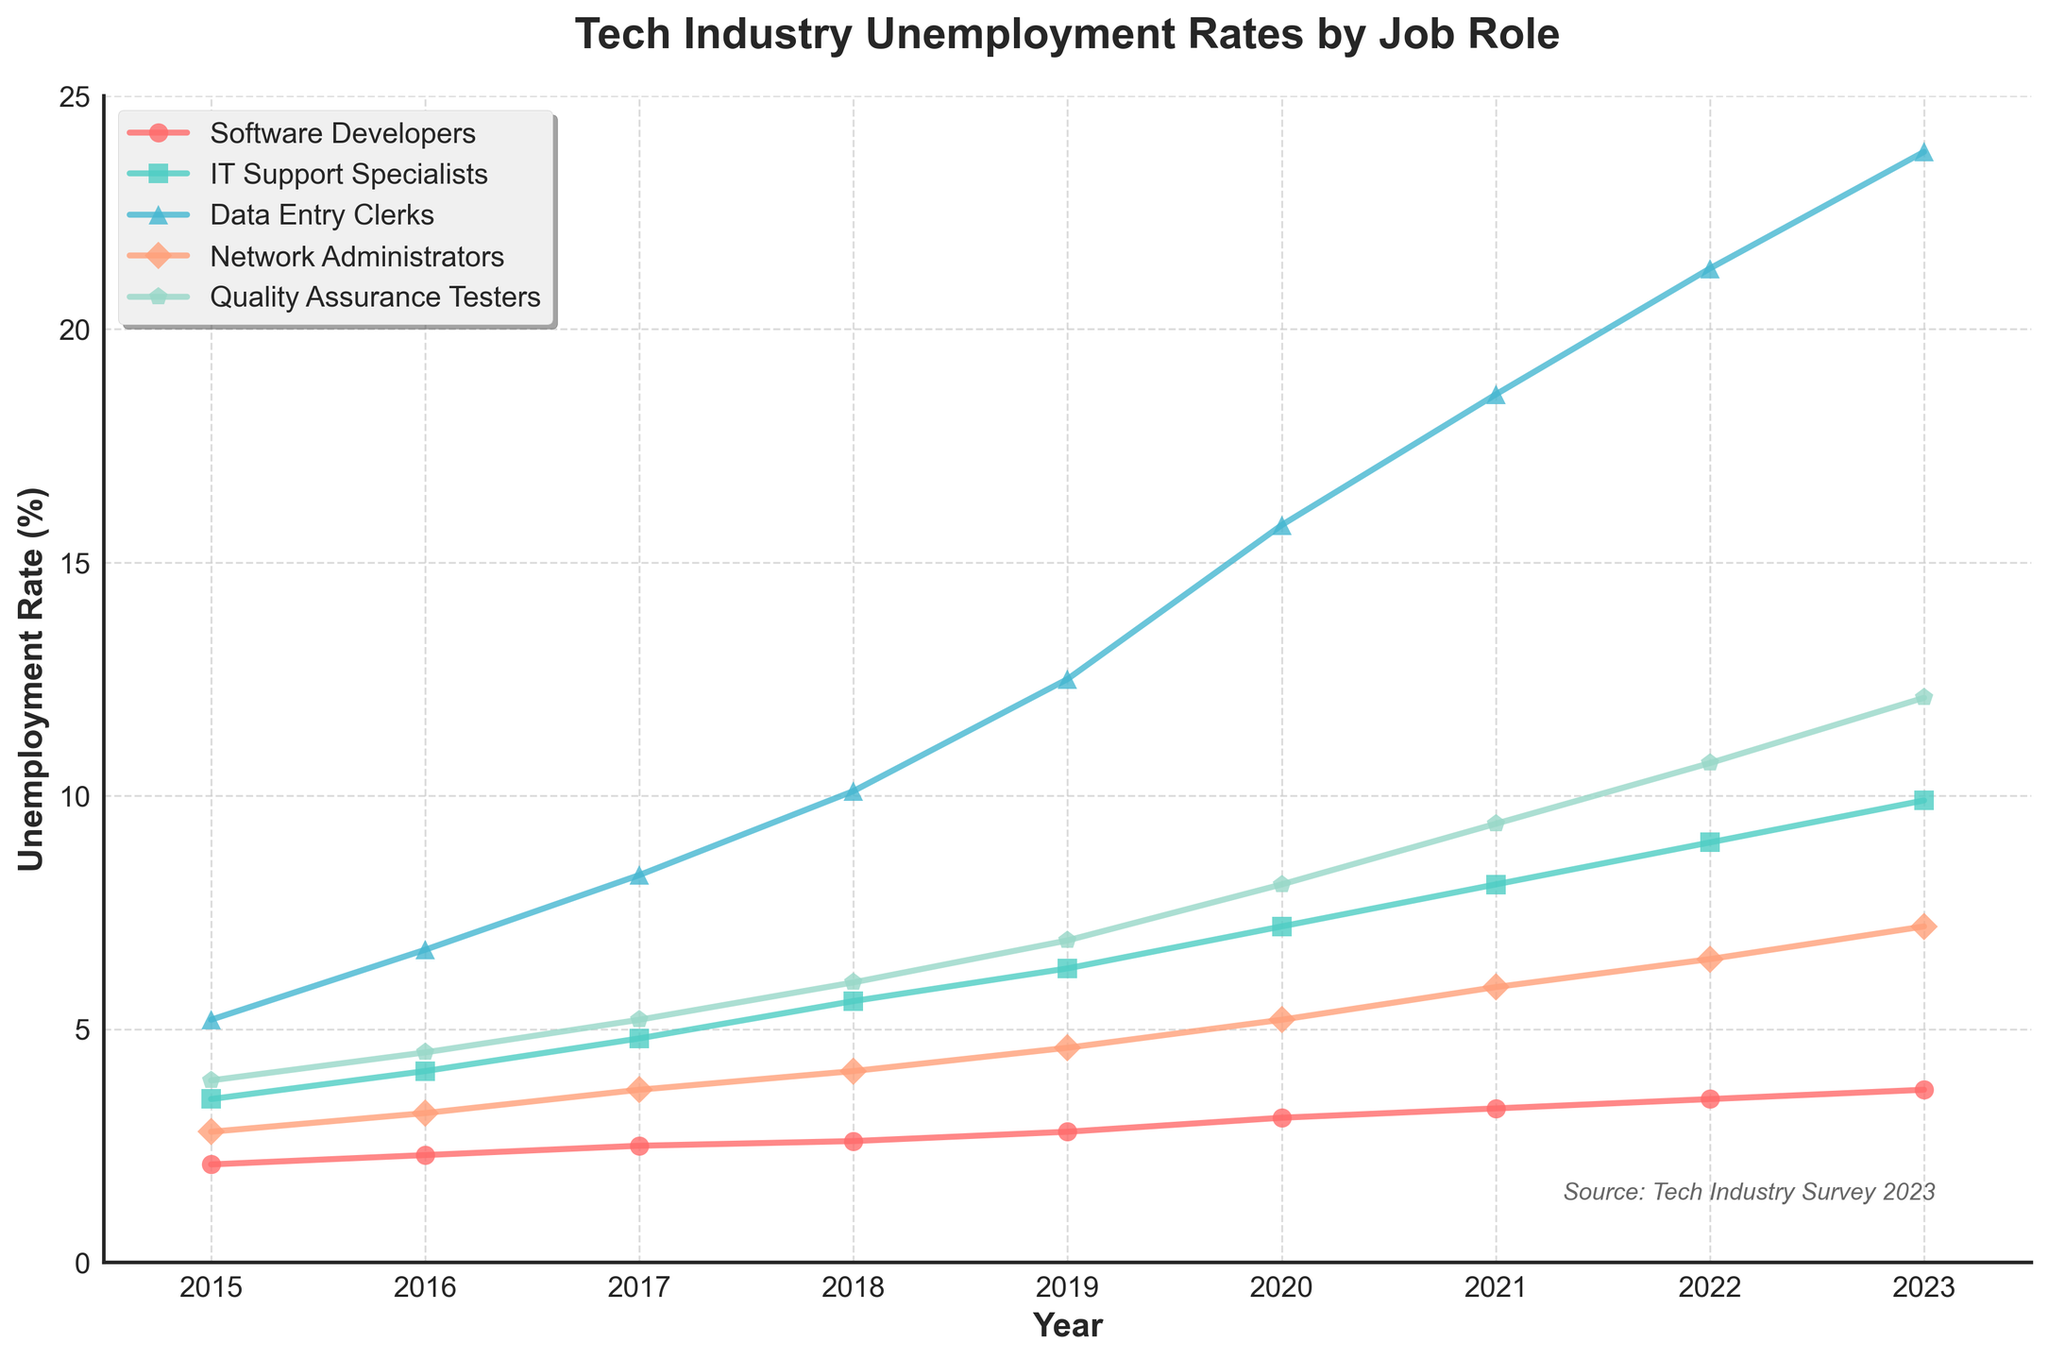What's the unemployment rate for Quality Assurance Testers in 2020? Look at the "Quality Assurance Testers" line for the year 2020. It is labeled as 8.1%.
Answer: 8.1% Which job role had the highest unemployment rate in 2023? Compare the unemployment rates of all job roles in the year 2023. "Data Entry Clerks" have the highest rate at 23.8%.
Answer: Data Entry Clerks How much did the unemployment rate for IT Support Specialists increase between 2015 and 2023? Find the unemployment rates for IT Support Specialists in 2015 and 2023 (3.5% and 9.9% respectively). Calculate the difference: 9.9% - 3.5% = 6.4%.
Answer: 6.4% Which job role has the most significant trend in increasing unemployment rates from 2015 to 2023? Compare the slopes of the lines for all job roles from 2015 to 2023. "Data Entry Clerks" has the steepest slope, indicating the most significant increase.
Answer: Data Entry Clerks What is the average unemployment rate for Network Administrators from 2015 to 2023? Sum the unemployment rates for Network Administrators from 2015 to 2023 (2.8, 3.2, 3.7, 4.1, 4.6, 5.2, 5.9, 6.5, 7.2) and divide by the number of years (9): (2.8 + 3.2 + 3.7 + 4.1 + 4.6 + 5.2 + 5.9 + 6.5 + 7.2) / 9 = 4.69%.
Answer: 4.69% Did the unemployment rate for Software Developers ever surpass that of IT Support Specialists between 2015 and 2023? Compare the unemployment rates of Software Developers and IT Support Specialists for each year. Software Developers' unemployment rates never surpassed those of IT Support Specialists.
Answer: No What is the color used to represent the unemployment rates of Software Developers in the plot? Identify the color of the line for Software Developers, which is red.
Answer: red 